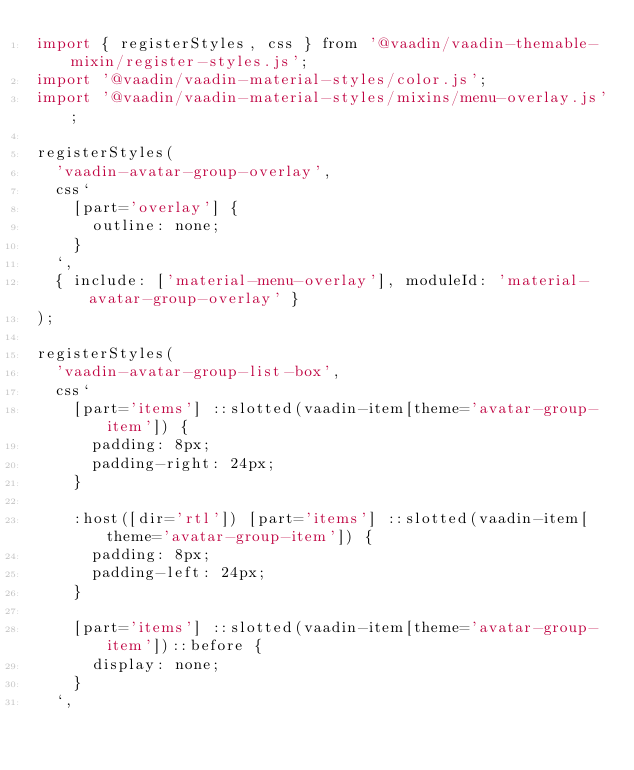<code> <loc_0><loc_0><loc_500><loc_500><_JavaScript_>import { registerStyles, css } from '@vaadin/vaadin-themable-mixin/register-styles.js';
import '@vaadin/vaadin-material-styles/color.js';
import '@vaadin/vaadin-material-styles/mixins/menu-overlay.js';

registerStyles(
  'vaadin-avatar-group-overlay',
  css`
    [part='overlay'] {
      outline: none;
    }
  `,
  { include: ['material-menu-overlay'], moduleId: 'material-avatar-group-overlay' }
);

registerStyles(
  'vaadin-avatar-group-list-box',
  css`
    [part='items'] ::slotted(vaadin-item[theme='avatar-group-item']) {
      padding: 8px;
      padding-right: 24px;
    }

    :host([dir='rtl']) [part='items'] ::slotted(vaadin-item[theme='avatar-group-item']) {
      padding: 8px;
      padding-left: 24px;
    }

    [part='items'] ::slotted(vaadin-item[theme='avatar-group-item'])::before {
      display: none;
    }
  `,</code> 